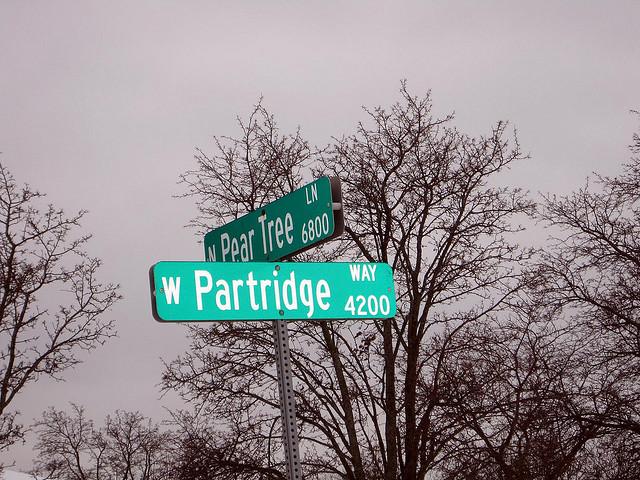Is it winter?
Give a very brief answer. Yes. What is the number on the street sign on Pear Tree?
Write a very short answer. 6800. How tall are the trees?
Concise answer only. Tall. What is the name of the Avenue?
Short answer required. Partridge. What number do these two signs have in common?
Quick response, please. 0. Is it winter or fall?
Write a very short answer. Winter. What intersection is this?
Short answer required. Partridge and pear tree. 